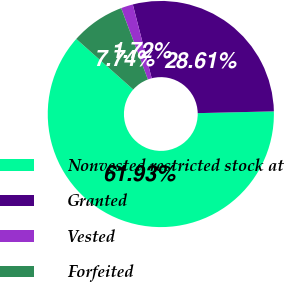<chart> <loc_0><loc_0><loc_500><loc_500><pie_chart><fcel>Nonvested restricted stock at<fcel>Granted<fcel>Vested<fcel>Forfeited<nl><fcel>61.93%<fcel>28.61%<fcel>1.72%<fcel>7.74%<nl></chart> 